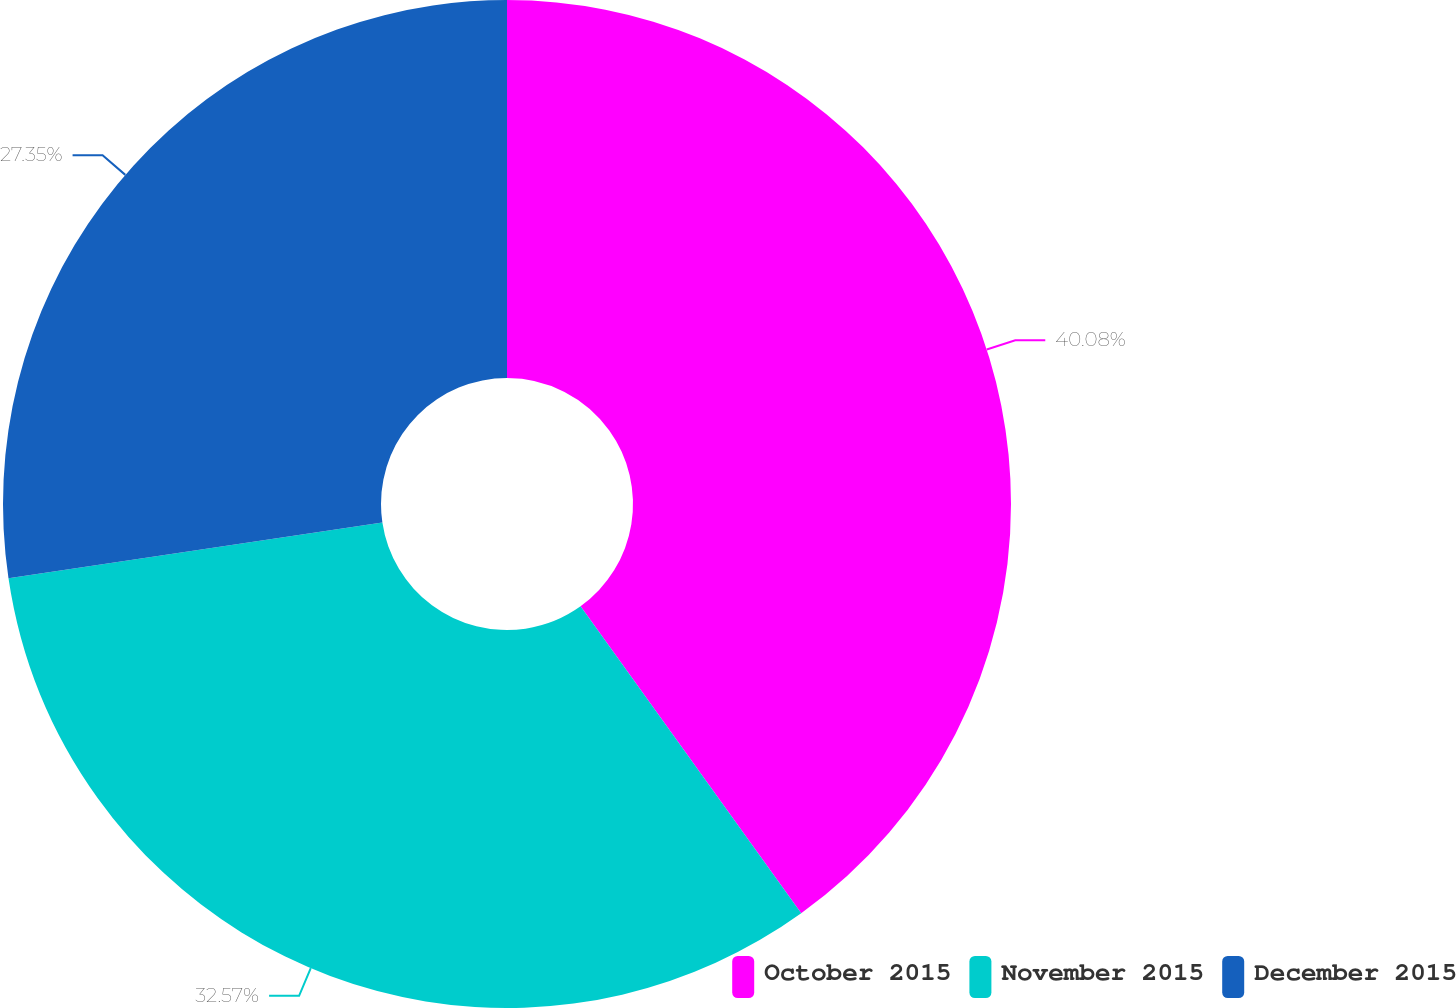Convert chart to OTSL. <chart><loc_0><loc_0><loc_500><loc_500><pie_chart><fcel>October 2015<fcel>November 2015<fcel>December 2015<nl><fcel>40.08%<fcel>32.57%<fcel>27.35%<nl></chart> 